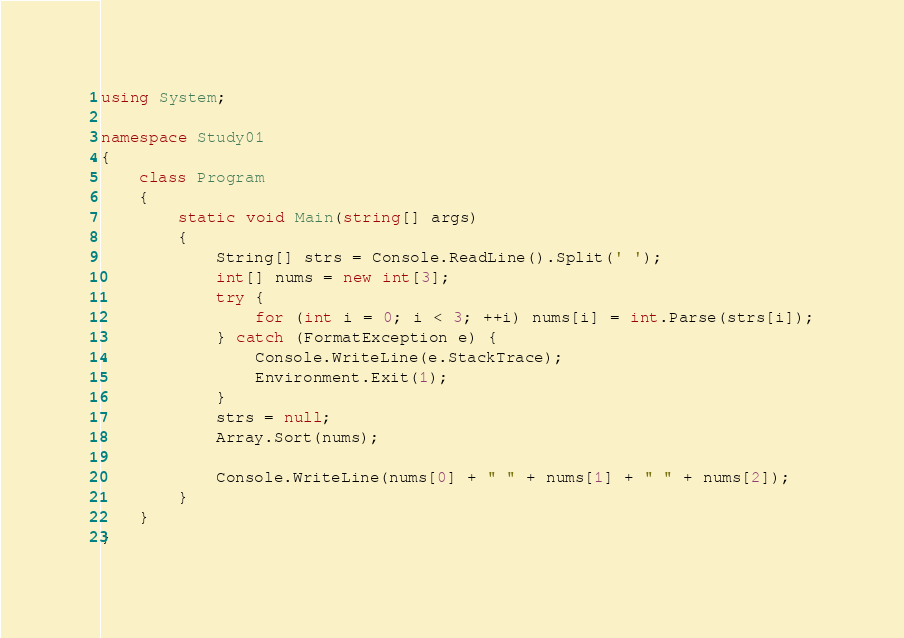Convert code to text. <code><loc_0><loc_0><loc_500><loc_500><_C#_>using System;

namespace Study01
{
    class Program
    {
        static void Main(string[] args)
        {
            String[] strs = Console.ReadLine().Split(' ');
            int[] nums = new int[3];
            try {
                for (int i = 0; i < 3; ++i) nums[i] = int.Parse(strs[i]);
            } catch (FormatException e) {
                Console.WriteLine(e.StackTrace);
                Environment.Exit(1);
            }
            strs = null;
            Array.Sort(nums);
            
            Console.WriteLine(nums[0] + " " + nums[1] + " " + nums[2]);
        }
    }
}</code> 